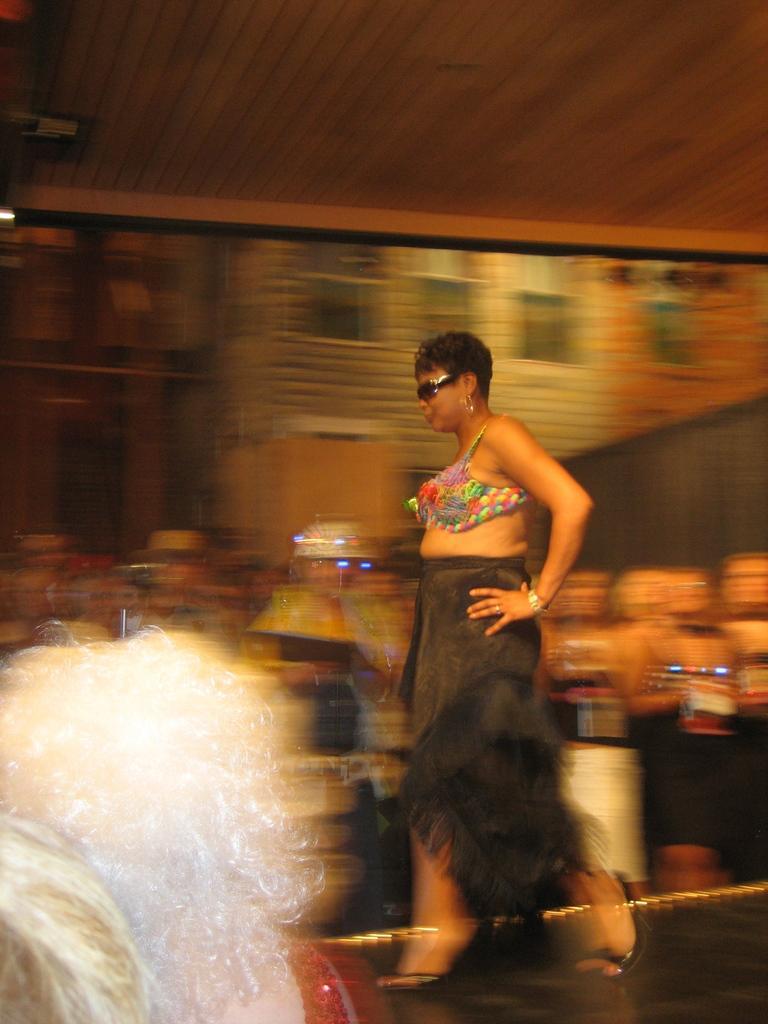How would you summarize this image in a sentence or two? In this image a woman is walking on the floor. Behind her there are few persons standing on the floor. This woman is wearing goggles. Left bottom there are few persons. Top of image there is wall. 